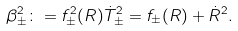<formula> <loc_0><loc_0><loc_500><loc_500>\beta _ { \pm } ^ { 2 } \colon = f _ { \pm } ^ { 2 } ( R ) \dot { T } _ { \pm } ^ { 2 } = f _ { \pm } ( R ) + \dot { R } ^ { 2 } .</formula> 